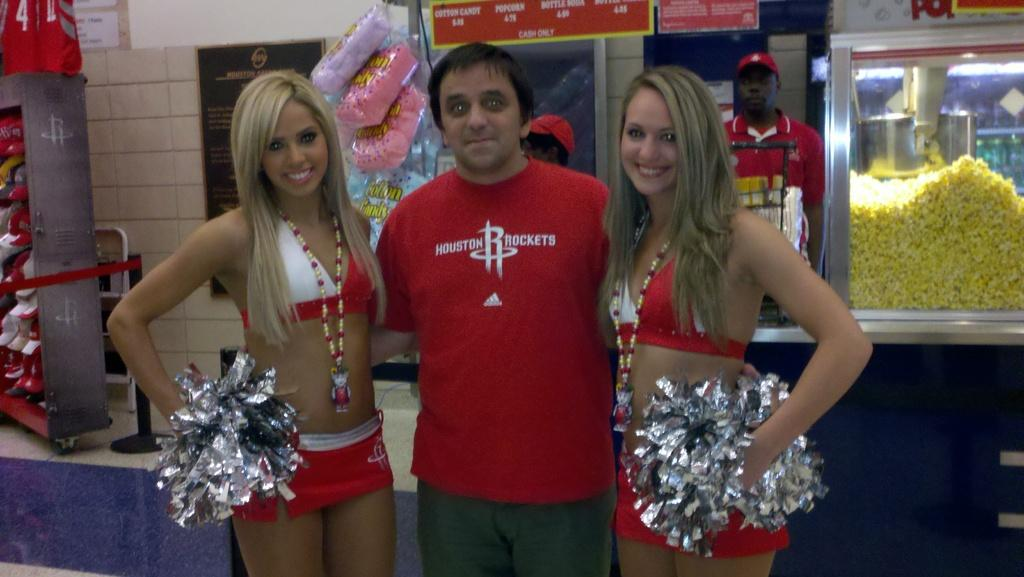Provide a one-sentence caption for the provided image. A man wearing a Houston Rockets t-shirt stands in between two cheerleaders. 